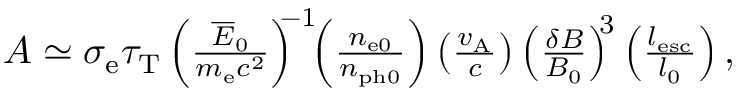<formula> <loc_0><loc_0><loc_500><loc_500>\begin{array} { r } { A \simeq \sigma _ { e } \tau _ { T } \left ( \frac { \overline { E } _ { 0 } } { m _ { e } c ^ { 2 } } \right ) ^ { \, - 1 } \, \left ( \frac { n _ { e 0 } } { n _ { p h 0 } } \right ) \left ( \frac { v _ { A } } { c } \right ) \left ( \frac { \delta B } { B _ { 0 } } \right ) ^ { \, 3 } \left ( \frac { l _ { e s c } } { l _ { 0 } } \right ) , } \end{array}</formula> 